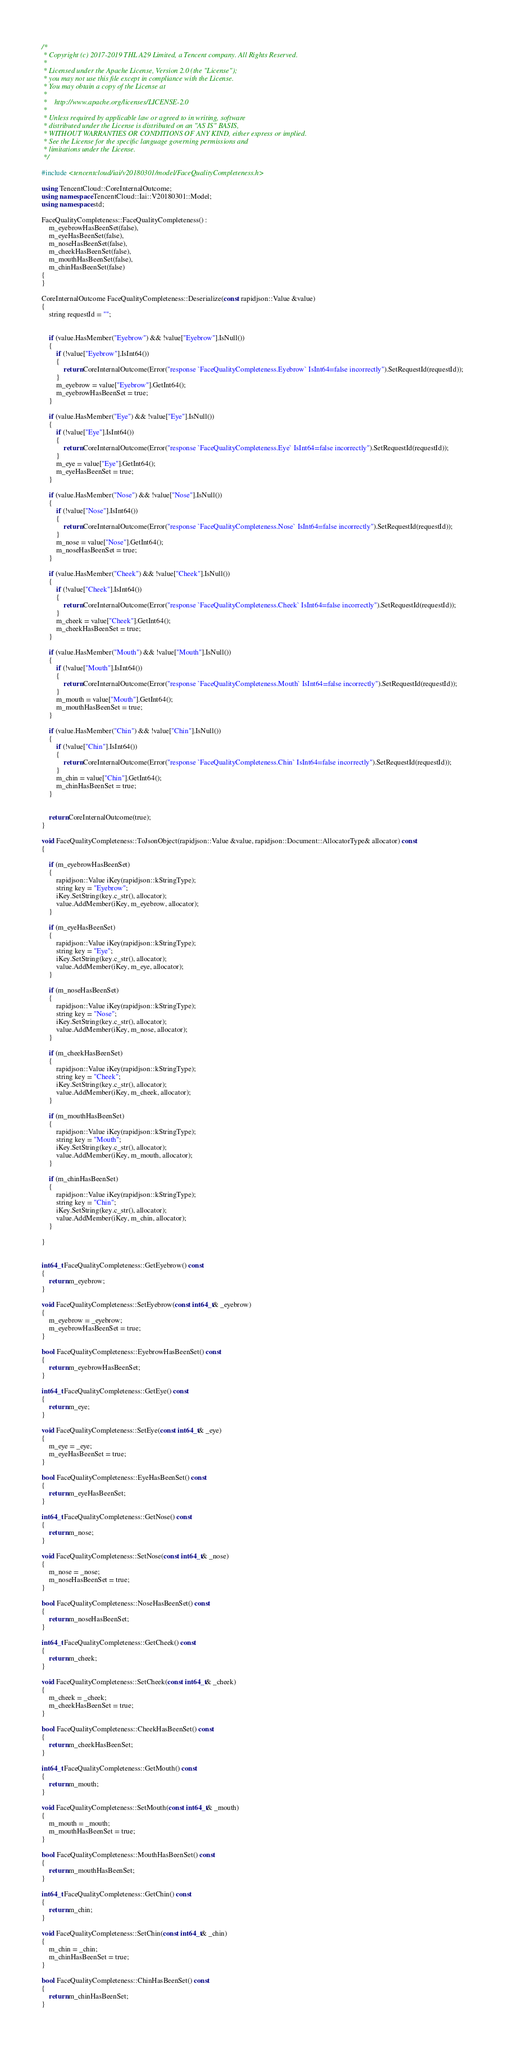Convert code to text. <code><loc_0><loc_0><loc_500><loc_500><_C++_>/*
 * Copyright (c) 2017-2019 THL A29 Limited, a Tencent company. All Rights Reserved.
 *
 * Licensed under the Apache License, Version 2.0 (the "License");
 * you may not use this file except in compliance with the License.
 * You may obtain a copy of the License at
 *
 *    http://www.apache.org/licenses/LICENSE-2.0
 *
 * Unless required by applicable law or agreed to in writing, software
 * distributed under the License is distributed on an "AS IS" BASIS,
 * WITHOUT WARRANTIES OR CONDITIONS OF ANY KIND, either express or implied.
 * See the License for the specific language governing permissions and
 * limitations under the License.
 */

#include <tencentcloud/iai/v20180301/model/FaceQualityCompleteness.h>

using TencentCloud::CoreInternalOutcome;
using namespace TencentCloud::Iai::V20180301::Model;
using namespace std;

FaceQualityCompleteness::FaceQualityCompleteness() :
    m_eyebrowHasBeenSet(false),
    m_eyeHasBeenSet(false),
    m_noseHasBeenSet(false),
    m_cheekHasBeenSet(false),
    m_mouthHasBeenSet(false),
    m_chinHasBeenSet(false)
{
}

CoreInternalOutcome FaceQualityCompleteness::Deserialize(const rapidjson::Value &value)
{
    string requestId = "";


    if (value.HasMember("Eyebrow") && !value["Eyebrow"].IsNull())
    {
        if (!value["Eyebrow"].IsInt64())
        {
            return CoreInternalOutcome(Error("response `FaceQualityCompleteness.Eyebrow` IsInt64=false incorrectly").SetRequestId(requestId));
        }
        m_eyebrow = value["Eyebrow"].GetInt64();
        m_eyebrowHasBeenSet = true;
    }

    if (value.HasMember("Eye") && !value["Eye"].IsNull())
    {
        if (!value["Eye"].IsInt64())
        {
            return CoreInternalOutcome(Error("response `FaceQualityCompleteness.Eye` IsInt64=false incorrectly").SetRequestId(requestId));
        }
        m_eye = value["Eye"].GetInt64();
        m_eyeHasBeenSet = true;
    }

    if (value.HasMember("Nose") && !value["Nose"].IsNull())
    {
        if (!value["Nose"].IsInt64())
        {
            return CoreInternalOutcome(Error("response `FaceQualityCompleteness.Nose` IsInt64=false incorrectly").SetRequestId(requestId));
        }
        m_nose = value["Nose"].GetInt64();
        m_noseHasBeenSet = true;
    }

    if (value.HasMember("Cheek") && !value["Cheek"].IsNull())
    {
        if (!value["Cheek"].IsInt64())
        {
            return CoreInternalOutcome(Error("response `FaceQualityCompleteness.Cheek` IsInt64=false incorrectly").SetRequestId(requestId));
        }
        m_cheek = value["Cheek"].GetInt64();
        m_cheekHasBeenSet = true;
    }

    if (value.HasMember("Mouth") && !value["Mouth"].IsNull())
    {
        if (!value["Mouth"].IsInt64())
        {
            return CoreInternalOutcome(Error("response `FaceQualityCompleteness.Mouth` IsInt64=false incorrectly").SetRequestId(requestId));
        }
        m_mouth = value["Mouth"].GetInt64();
        m_mouthHasBeenSet = true;
    }

    if (value.HasMember("Chin") && !value["Chin"].IsNull())
    {
        if (!value["Chin"].IsInt64())
        {
            return CoreInternalOutcome(Error("response `FaceQualityCompleteness.Chin` IsInt64=false incorrectly").SetRequestId(requestId));
        }
        m_chin = value["Chin"].GetInt64();
        m_chinHasBeenSet = true;
    }


    return CoreInternalOutcome(true);
}

void FaceQualityCompleteness::ToJsonObject(rapidjson::Value &value, rapidjson::Document::AllocatorType& allocator) const
{

    if (m_eyebrowHasBeenSet)
    {
        rapidjson::Value iKey(rapidjson::kStringType);
        string key = "Eyebrow";
        iKey.SetString(key.c_str(), allocator);
        value.AddMember(iKey, m_eyebrow, allocator);
    }

    if (m_eyeHasBeenSet)
    {
        rapidjson::Value iKey(rapidjson::kStringType);
        string key = "Eye";
        iKey.SetString(key.c_str(), allocator);
        value.AddMember(iKey, m_eye, allocator);
    }

    if (m_noseHasBeenSet)
    {
        rapidjson::Value iKey(rapidjson::kStringType);
        string key = "Nose";
        iKey.SetString(key.c_str(), allocator);
        value.AddMember(iKey, m_nose, allocator);
    }

    if (m_cheekHasBeenSet)
    {
        rapidjson::Value iKey(rapidjson::kStringType);
        string key = "Cheek";
        iKey.SetString(key.c_str(), allocator);
        value.AddMember(iKey, m_cheek, allocator);
    }

    if (m_mouthHasBeenSet)
    {
        rapidjson::Value iKey(rapidjson::kStringType);
        string key = "Mouth";
        iKey.SetString(key.c_str(), allocator);
        value.AddMember(iKey, m_mouth, allocator);
    }

    if (m_chinHasBeenSet)
    {
        rapidjson::Value iKey(rapidjson::kStringType);
        string key = "Chin";
        iKey.SetString(key.c_str(), allocator);
        value.AddMember(iKey, m_chin, allocator);
    }

}


int64_t FaceQualityCompleteness::GetEyebrow() const
{
    return m_eyebrow;
}

void FaceQualityCompleteness::SetEyebrow(const int64_t& _eyebrow)
{
    m_eyebrow = _eyebrow;
    m_eyebrowHasBeenSet = true;
}

bool FaceQualityCompleteness::EyebrowHasBeenSet() const
{
    return m_eyebrowHasBeenSet;
}

int64_t FaceQualityCompleteness::GetEye() const
{
    return m_eye;
}

void FaceQualityCompleteness::SetEye(const int64_t& _eye)
{
    m_eye = _eye;
    m_eyeHasBeenSet = true;
}

bool FaceQualityCompleteness::EyeHasBeenSet() const
{
    return m_eyeHasBeenSet;
}

int64_t FaceQualityCompleteness::GetNose() const
{
    return m_nose;
}

void FaceQualityCompleteness::SetNose(const int64_t& _nose)
{
    m_nose = _nose;
    m_noseHasBeenSet = true;
}

bool FaceQualityCompleteness::NoseHasBeenSet() const
{
    return m_noseHasBeenSet;
}

int64_t FaceQualityCompleteness::GetCheek() const
{
    return m_cheek;
}

void FaceQualityCompleteness::SetCheek(const int64_t& _cheek)
{
    m_cheek = _cheek;
    m_cheekHasBeenSet = true;
}

bool FaceQualityCompleteness::CheekHasBeenSet() const
{
    return m_cheekHasBeenSet;
}

int64_t FaceQualityCompleteness::GetMouth() const
{
    return m_mouth;
}

void FaceQualityCompleteness::SetMouth(const int64_t& _mouth)
{
    m_mouth = _mouth;
    m_mouthHasBeenSet = true;
}

bool FaceQualityCompleteness::MouthHasBeenSet() const
{
    return m_mouthHasBeenSet;
}

int64_t FaceQualityCompleteness::GetChin() const
{
    return m_chin;
}

void FaceQualityCompleteness::SetChin(const int64_t& _chin)
{
    m_chin = _chin;
    m_chinHasBeenSet = true;
}

bool FaceQualityCompleteness::ChinHasBeenSet() const
{
    return m_chinHasBeenSet;
}

</code> 